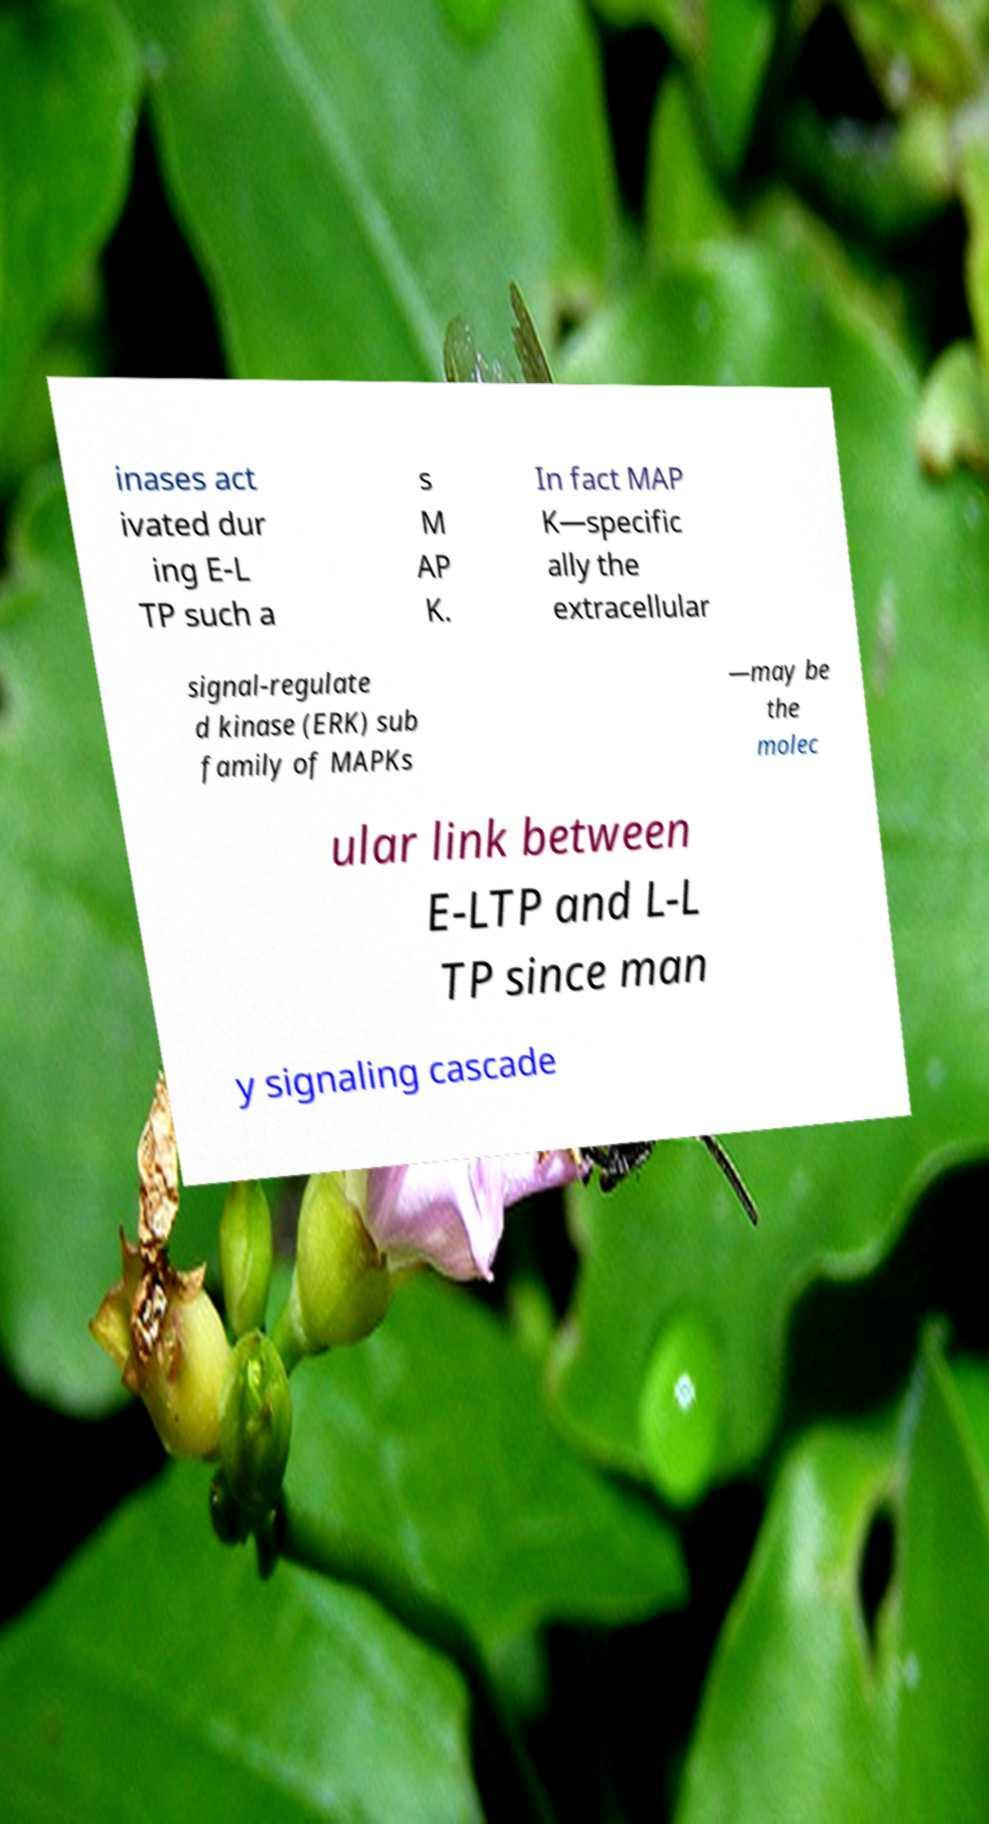Please identify and transcribe the text found in this image. inases act ivated dur ing E-L TP such a s M AP K. In fact MAP K—specific ally the extracellular signal-regulate d kinase (ERK) sub family of MAPKs —may be the molec ular link between E-LTP and L-L TP since man y signaling cascade 